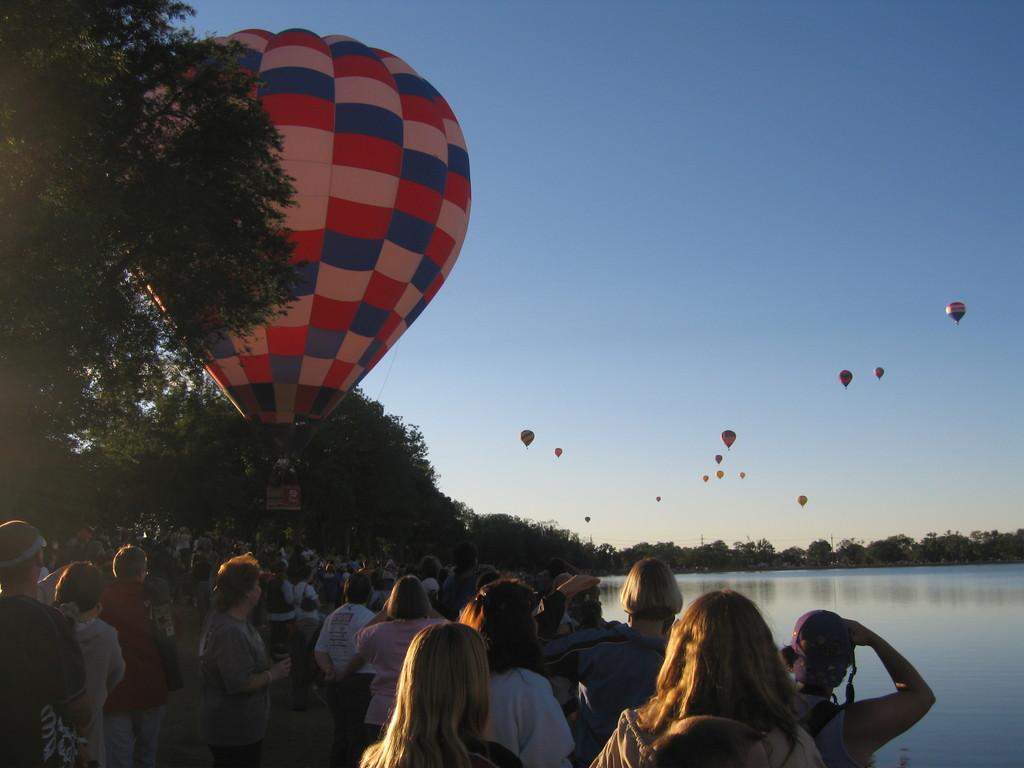In one or two sentences, can you explain what this image depicts? People are standing. There is water on the right and trees at the back. There are air balloons in the sky. 